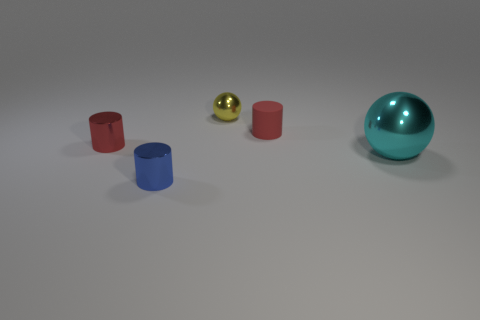Is there any other thing that has the same size as the cyan metal object?
Make the answer very short. No. The red shiny object that is the same size as the yellow ball is what shape?
Ensure brevity in your answer.  Cylinder. Are there more cyan metal spheres than gray shiny things?
Keep it short and to the point. Yes. What material is the thing that is both on the right side of the yellow thing and on the left side of the cyan metallic object?
Give a very brief answer. Rubber. How many small cylinders are the same color as the matte object?
Your answer should be compact. 1. How big is the red cylinder in front of the small red cylinder to the right of the small red object that is left of the yellow ball?
Your response must be concise. Small. How many metal objects are either large cyan balls or tiny red objects?
Give a very brief answer. 2. There is a big metal object; does it have the same shape as the yellow thing that is to the right of the tiny blue shiny cylinder?
Your response must be concise. Yes. Are there more things in front of the large sphere than small blue metallic objects that are to the right of the tiny red matte cylinder?
Your answer should be very brief. Yes. Are there any other things that are the same color as the big thing?
Keep it short and to the point. No. 